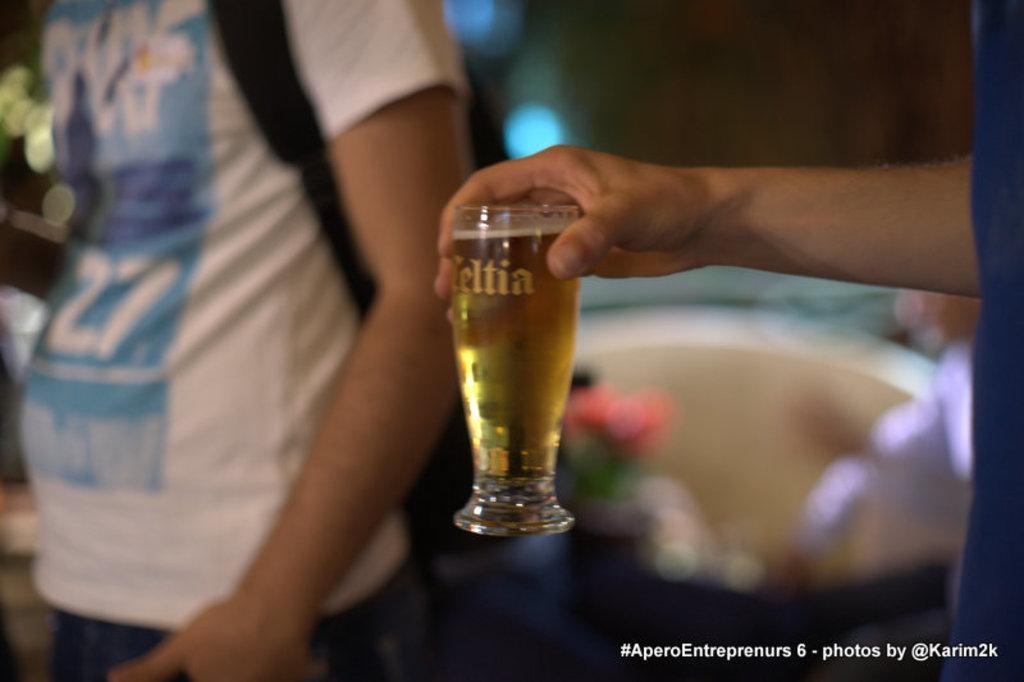How would you summarize this image in a sentence or two? Here we can see hand of a person holding a glass with drink and there is a person. Here we can see watermark and there is a blur background. 